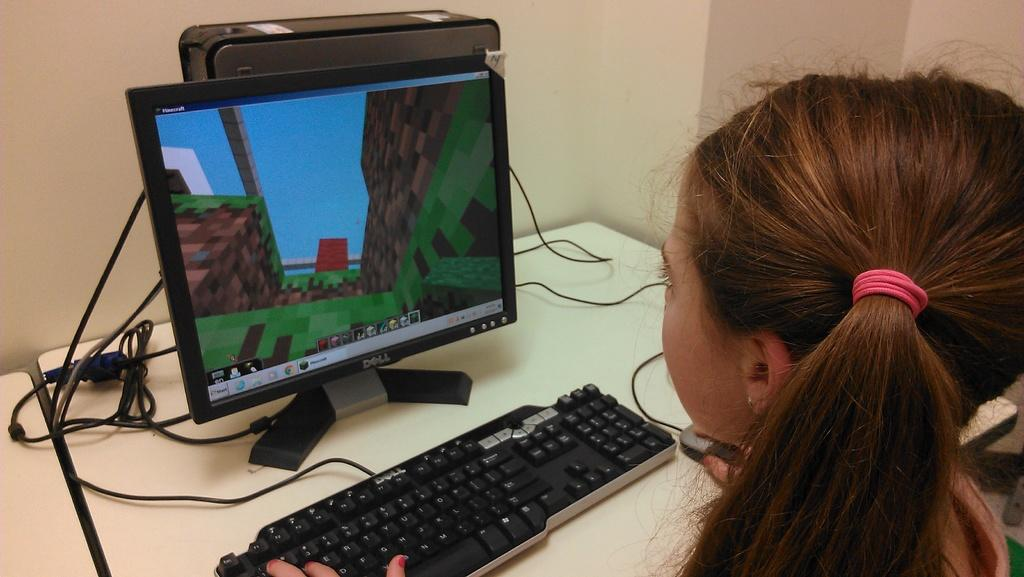<image>
Present a compact description of the photo's key features. A girl playing a game on a Dell computer. 